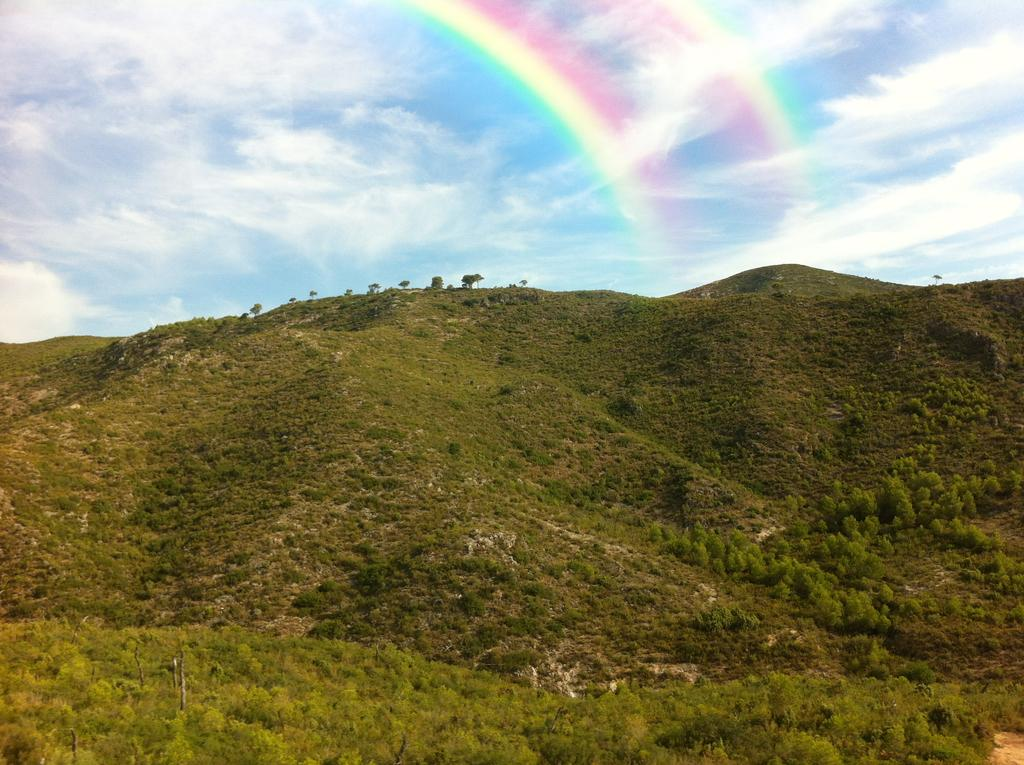What is the main geographical feature in the image? There is a mountain in the image. What can be seen on the mountain? There are trees and plants on the mountain. What is visible at the top of the mountain? The sky is visible at the top of the mountain. What natural phenomenon can be seen in the sky? There is a double rainbow in the sky. How many tickets are required to enter the mountain in the image? There is no mention of tickets or any entrance to the mountain in the image. Can you see any mice running around on the mountain in the image? There are no mice visible in the image; it features a mountain with trees, plants, and a double rainbow in the sky. 